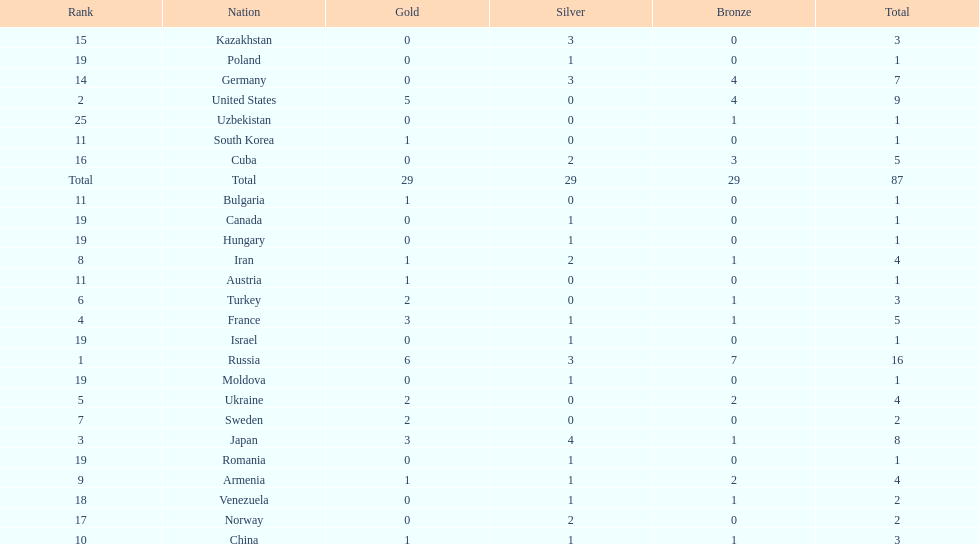Who ranked right after turkey? Sweden. 